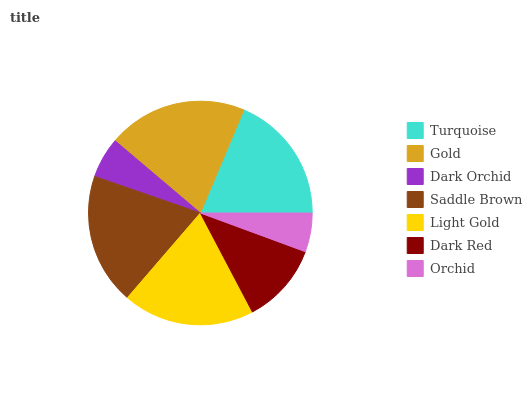Is Orchid the minimum?
Answer yes or no. Yes. Is Gold the maximum?
Answer yes or no. Yes. Is Dark Orchid the minimum?
Answer yes or no. No. Is Dark Orchid the maximum?
Answer yes or no. No. Is Gold greater than Dark Orchid?
Answer yes or no. Yes. Is Dark Orchid less than Gold?
Answer yes or no. Yes. Is Dark Orchid greater than Gold?
Answer yes or no. No. Is Gold less than Dark Orchid?
Answer yes or no. No. Is Turquoise the high median?
Answer yes or no. Yes. Is Turquoise the low median?
Answer yes or no. Yes. Is Dark Orchid the high median?
Answer yes or no. No. Is Light Gold the low median?
Answer yes or no. No. 